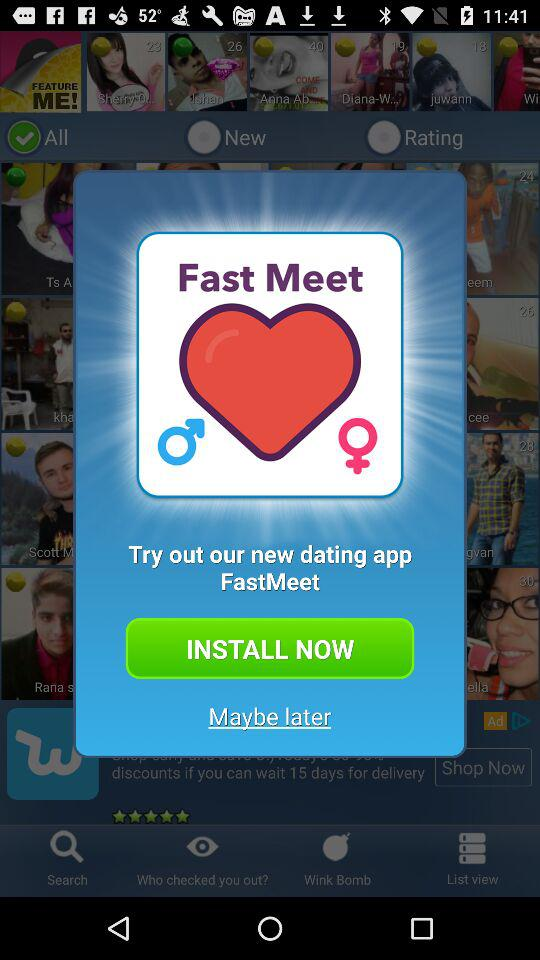What is the name of the application? The name of the application is "Fast Meet". 